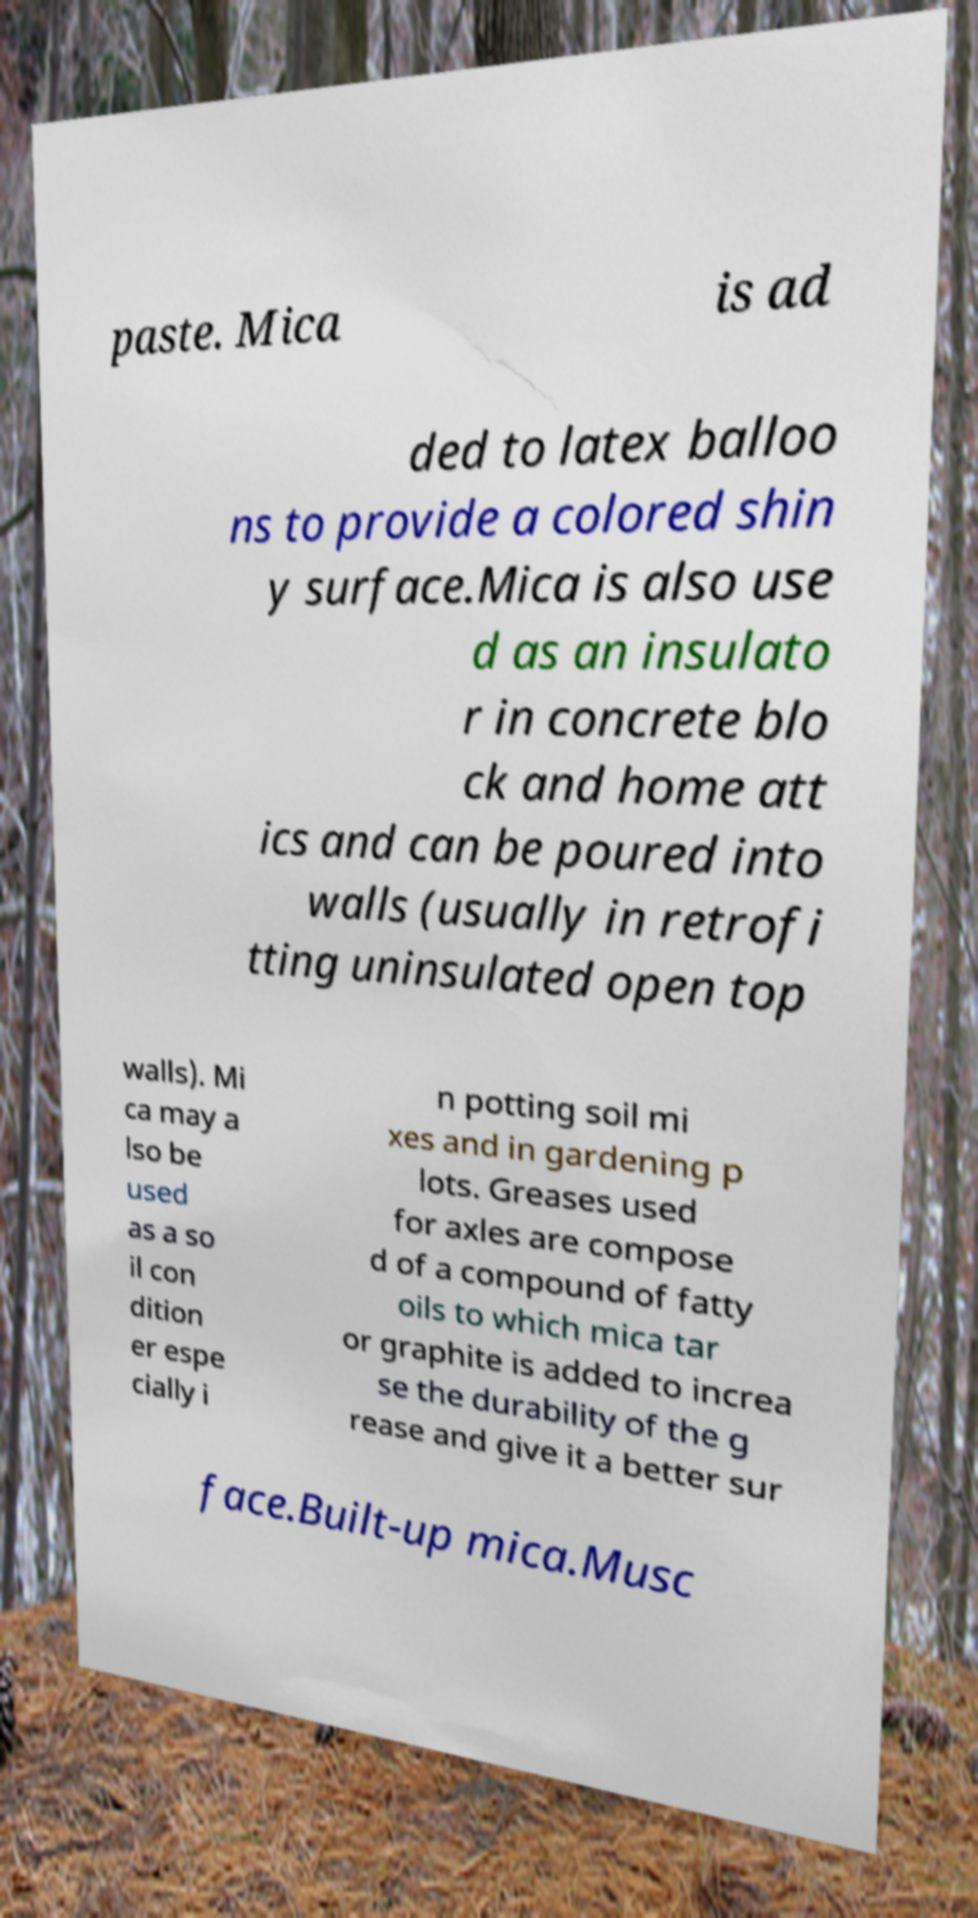I need the written content from this picture converted into text. Can you do that? paste. Mica is ad ded to latex balloo ns to provide a colored shin y surface.Mica is also use d as an insulato r in concrete blo ck and home att ics and can be poured into walls (usually in retrofi tting uninsulated open top walls). Mi ca may a lso be used as a so il con dition er espe cially i n potting soil mi xes and in gardening p lots. Greases used for axles are compose d of a compound of fatty oils to which mica tar or graphite is added to increa se the durability of the g rease and give it a better sur face.Built-up mica.Musc 